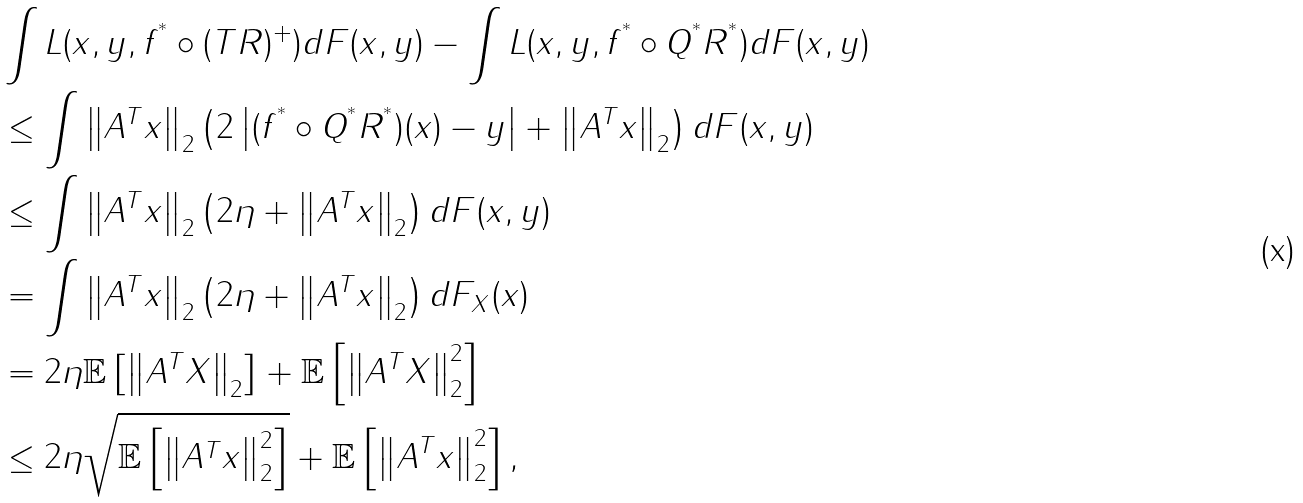<formula> <loc_0><loc_0><loc_500><loc_500>& \int L ( x , y , f ^ { ^ { * } } \circ ( T R ) ^ { + } ) d F ( x , y ) - \int L ( x , y , f ^ { ^ { * } } \circ Q ^ { ^ { * } } R ^ { ^ { * } } ) d F ( x , y ) \\ & \leq \int \left \| A ^ { T } x \right \| _ { 2 } \left ( 2 \left | ( f ^ { ^ { * } } \circ Q ^ { ^ { * } } R ^ { ^ { * } } ) ( x ) - y \right | + \left \| A ^ { T } x \right \| _ { 2 } \right ) d F ( x , y ) \\ & \leq \int \left \| A ^ { T } x \right \| _ { 2 } \left ( 2 \eta + \left \| A ^ { T } x \right \| _ { 2 } \right ) d F ( x , y ) \\ & = \int \left \| A ^ { T } x \right \| _ { 2 } \left ( 2 \eta + \left \| A ^ { T } x \right \| _ { 2 } \right ) d F _ { X } ( x ) \\ & = 2 \eta \mathbb { E } \left [ \left \| A ^ { T } X \right \| _ { 2 } \right ] + \mathbb { E } \left [ \left \| A ^ { T } X \right \| _ { 2 } ^ { 2 } \right ] \\ & \leq 2 \eta \sqrt { \mathbb { E } \left [ \left \| A ^ { T } x \right \| _ { 2 } ^ { 2 } \right ] } + \mathbb { E } \left [ \left \| A ^ { T } x \right \| _ { 2 } ^ { 2 } \right ] ,</formula> 